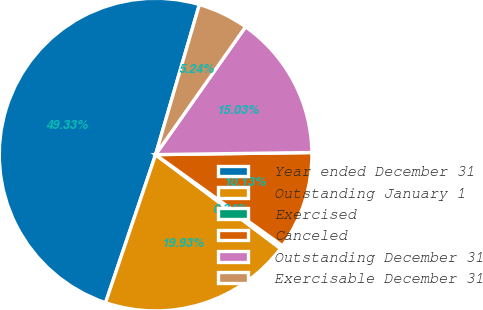Convert chart to OTSL. <chart><loc_0><loc_0><loc_500><loc_500><pie_chart><fcel>Year ended December 31<fcel>Outstanding January 1<fcel>Exercised<fcel>Canceled<fcel>Outstanding December 31<fcel>Exercisable December 31<nl><fcel>49.33%<fcel>19.93%<fcel>0.34%<fcel>10.13%<fcel>15.03%<fcel>5.24%<nl></chart> 